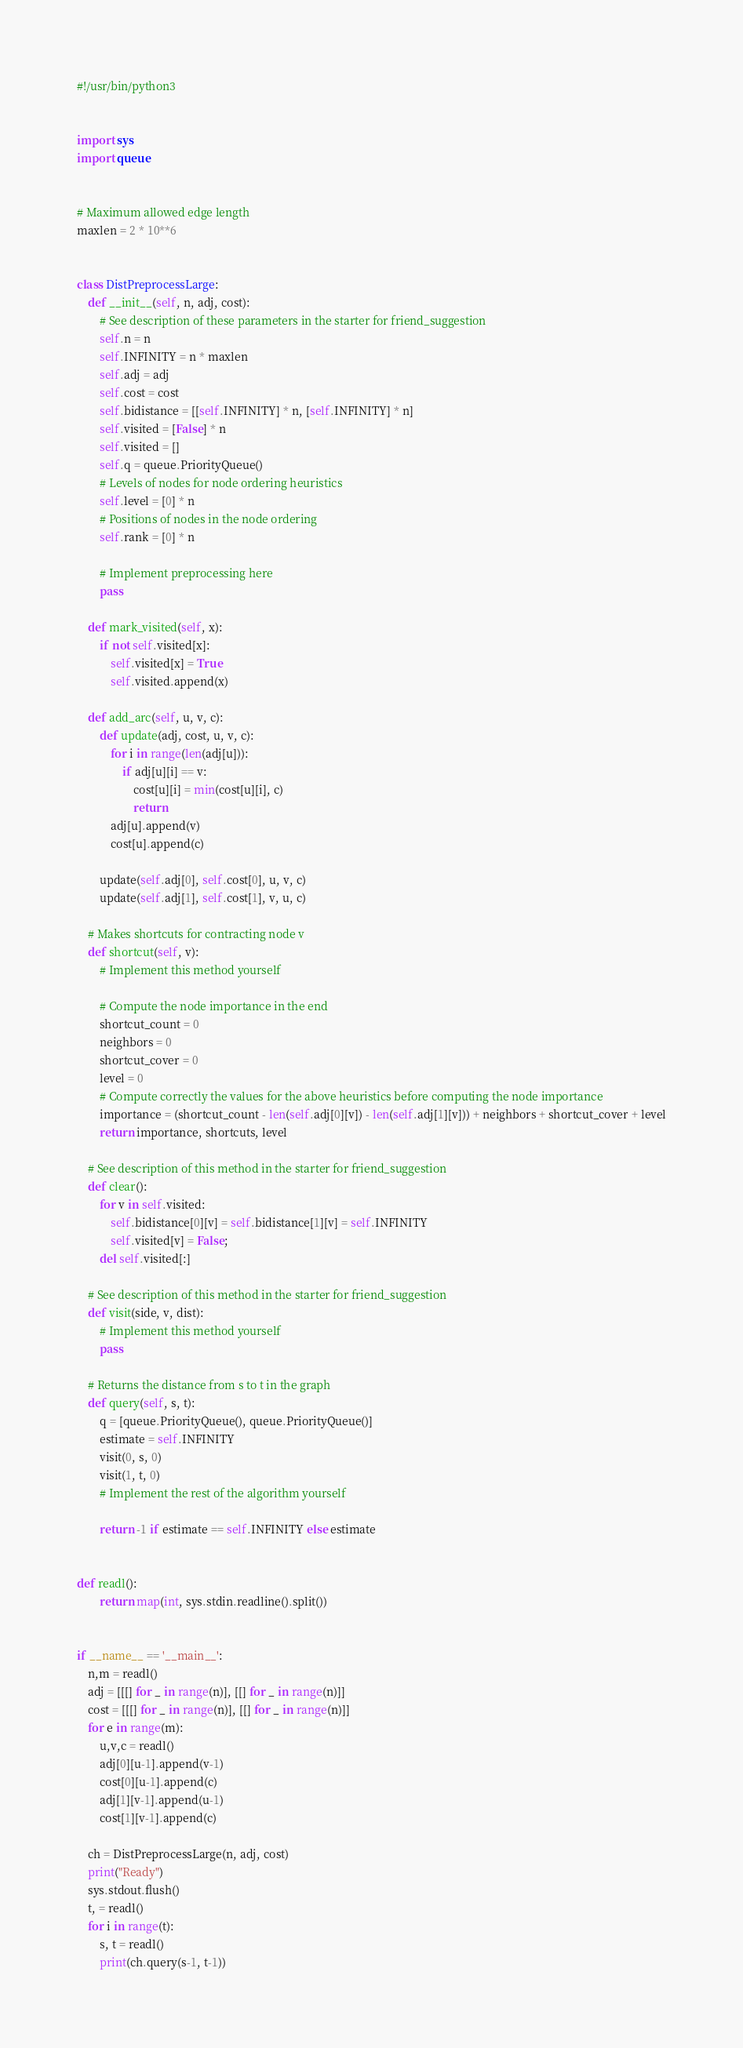Convert code to text. <code><loc_0><loc_0><loc_500><loc_500><_Python_>#!/usr/bin/python3


import sys
import queue


# Maximum allowed edge length
maxlen = 2 * 10**6


class DistPreprocessLarge:
    def __init__(self, n, adj, cost):
        # See description of these parameters in the starter for friend_suggestion
        self.n = n
        self.INFINITY = n * maxlen
        self.adj = adj
        self.cost = cost
        self.bidistance = [[self.INFINITY] * n, [self.INFINITY] * n]
        self.visited = [False] * n
        self.visited = []
        self.q = queue.PriorityQueue()
        # Levels of nodes for node ordering heuristics
        self.level = [0] * n
        # Positions of nodes in the node ordering
        self.rank = [0] * n

        # Implement preprocessing here
        pass

    def mark_visited(self, x):
        if not self.visited[x]:
            self.visited[x] = True
            self.visited.append(x)

    def add_arc(self, u, v, c):
        def update(adj, cost, u, v, c):
            for i in range(len(adj[u])):
                if adj[u][i] == v:
                    cost[u][i] = min(cost[u][i], c)
                    return
            adj[u].append(v)
            cost[u].append(c)

        update(self.adj[0], self.cost[0], u, v, c)
        update(self.adj[1], self.cost[1], v, u, c)

    # Makes shortcuts for contracting node v
    def shortcut(self, v):
        # Implement this method yourself

        # Compute the node importance in the end
        shortcut_count = 0
        neighbors = 0
        shortcut_cover = 0
        level = 0
        # Compute correctly the values for the above heuristics before computing the node importance
        importance = (shortcut_count - len(self.adj[0][v]) - len(self.adj[1][v])) + neighbors + shortcut_cover + level
        return importance, shortcuts, level

    # See description of this method in the starter for friend_suggestion
    def clear():
        for v in self.visited:
            self.bidistance[0][v] = self.bidistance[1][v] = self.INFINITY
            self.visited[v] = False;
        del self.visited[:]

    # See description of this method in the starter for friend_suggestion
    def visit(side, v, dist):
        # Implement this method yourself
        pass

    # Returns the distance from s to t in the graph
    def query(self, s, t):
        q = [queue.PriorityQueue(), queue.PriorityQueue()]
        estimate = self.INFINITY
        visit(0, s, 0)
        visit(1, t, 0)
        # Implement the rest of the algorithm yourself

        return -1 if estimate == self.INFINITY else estimate


def readl():
        return map(int, sys.stdin.readline().split())


if __name__ == '__main__':
    n,m = readl()
    adj = [[[] for _ in range(n)], [[] for _ in range(n)]]
    cost = [[[] for _ in range(n)], [[] for _ in range(n)]]
    for e in range(m):
        u,v,c = readl()
        adj[0][u-1].append(v-1)
        cost[0][u-1].append(c)
        adj[1][v-1].append(u-1)
        cost[1][v-1].append(c)

    ch = DistPreprocessLarge(n, adj, cost)
    print("Ready")
    sys.stdout.flush()
    t, = readl()
    for i in range(t):
        s, t = readl()
        print(ch.query(s-1, t-1))</code> 